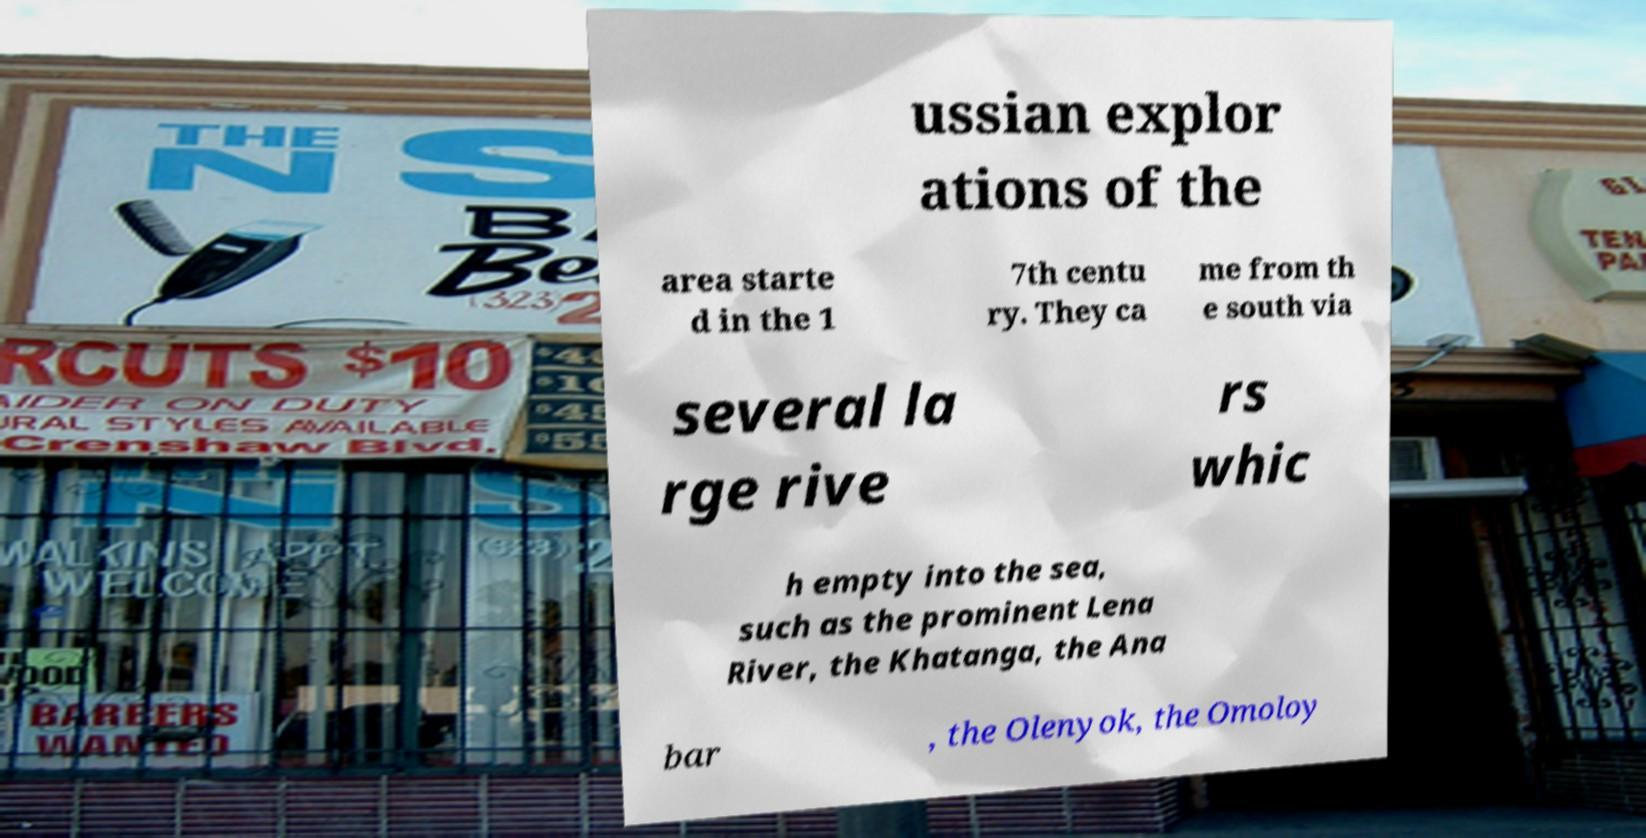Please identify and transcribe the text found in this image. ussian explor ations of the area starte d in the 1 7th centu ry. They ca me from th e south via several la rge rive rs whic h empty into the sea, such as the prominent Lena River, the Khatanga, the Ana bar , the Olenyok, the Omoloy 